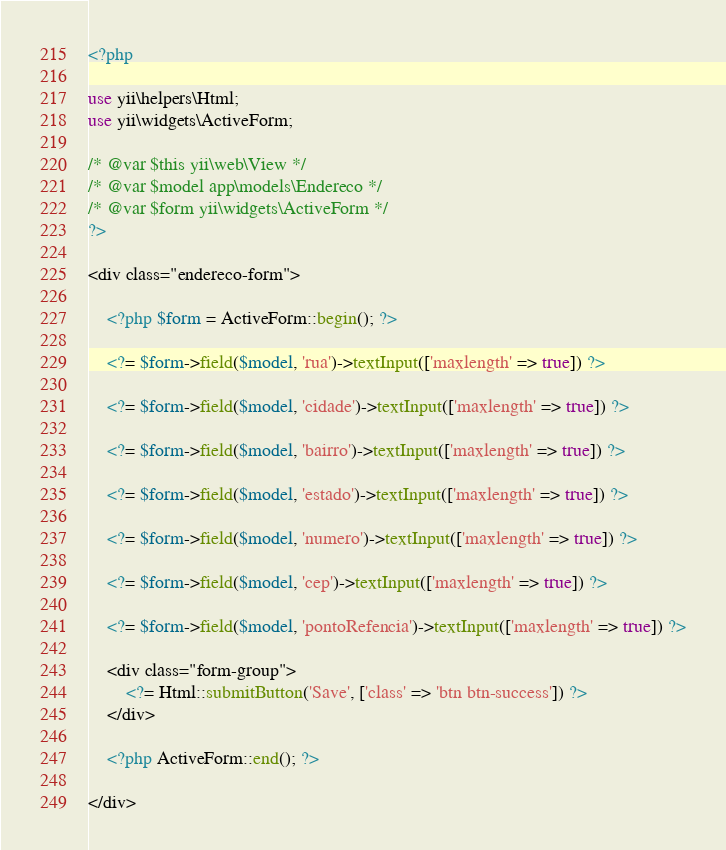Convert code to text. <code><loc_0><loc_0><loc_500><loc_500><_PHP_><?php

use yii\helpers\Html;
use yii\widgets\ActiveForm;

/* @var $this yii\web\View */
/* @var $model app\models\Endereco */
/* @var $form yii\widgets\ActiveForm */
?>

<div class="endereco-form">

    <?php $form = ActiveForm::begin(); ?>

    <?= $form->field($model, 'rua')->textInput(['maxlength' => true]) ?>

    <?= $form->field($model, 'cidade')->textInput(['maxlength' => true]) ?>

    <?= $form->field($model, 'bairro')->textInput(['maxlength' => true]) ?>

    <?= $form->field($model, 'estado')->textInput(['maxlength' => true]) ?>

    <?= $form->field($model, 'numero')->textInput(['maxlength' => true]) ?>

    <?= $form->field($model, 'cep')->textInput(['maxlength' => true]) ?>

    <?= $form->field($model, 'pontoRefencia')->textInput(['maxlength' => true]) ?>

    <div class="form-group">
        <?= Html::submitButton('Save', ['class' => 'btn btn-success']) ?>
    </div>

    <?php ActiveForm::end(); ?>

</div>
</code> 